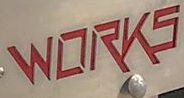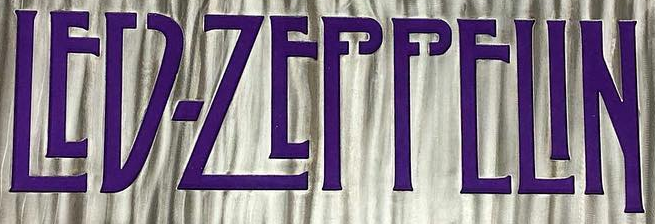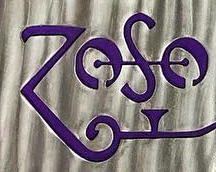What text appears in these images from left to right, separated by a semicolon? WORKS; LED-ZEPPELIN; ZOSO 